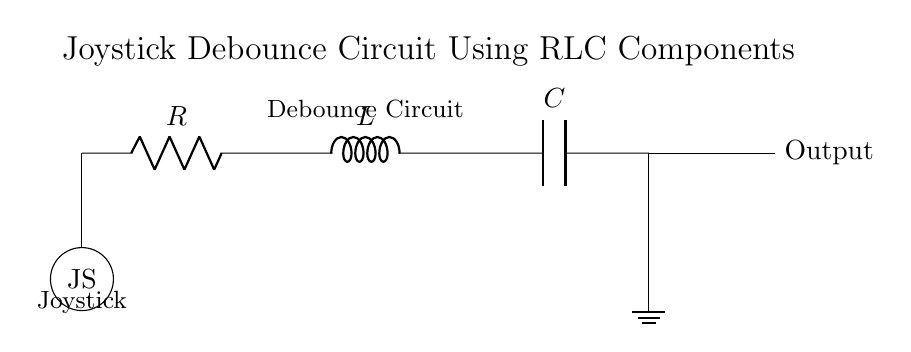What components are used in this debounce circuit? The components in the circuit are a resistor, an inductor, and a capacitor. These are the three essential components that form the RLC circuit.
Answer: Resistor, Inductor, Capacitor What is the role of the joystick in this circuit? The joystick acts as the input device that triggers the debounce circuit when moved, providing a signal that needs to be processed to eliminate noise.
Answer: Input device What is the output of the circuit? The output from the circuit is shown at the node after the capacitor, indicating that it generates a signal that can be used in further processing.
Answer: Output signal How many components are in series in this circuit? There are three components (the resistor, inductor, and capacitor) connected in series, sequentially connecting each component's terminals.
Answer: Three What type of circuit is depicted here? The circuit is classified as a RLC circuit, which includes one resistor, one inductor, and one capacitor, and is commonly used for filtering signals.
Answer: RLC circuit Why is debounce necessary in this joystick circuit? Debouncing is necessary to prevent erratic signals from being interpreted as multiple inputs when the joystick is pressed or released, improving reliability.
Answer: To prevent erratic signals 